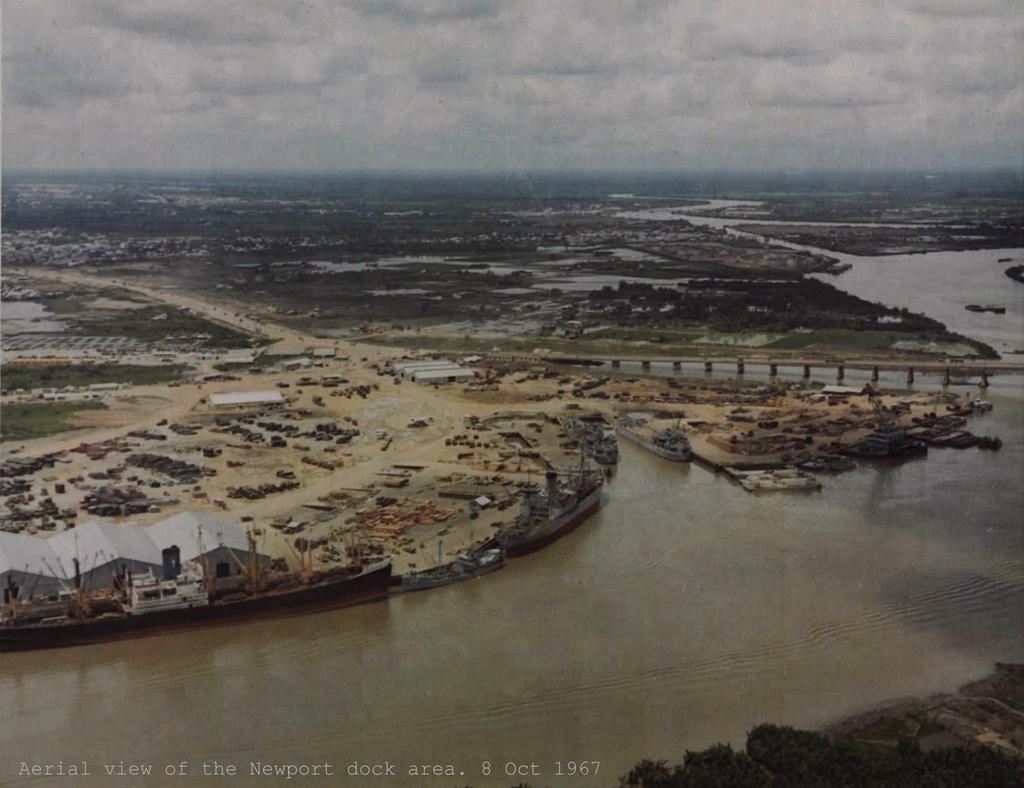Could you give a brief overview of what you see in this image? In this image at the bottom there is text, and in the center of the image there are some buildings, trees, poles, sand. On the right side there is a bridge, and there is water. At the top of the image there is sky. 